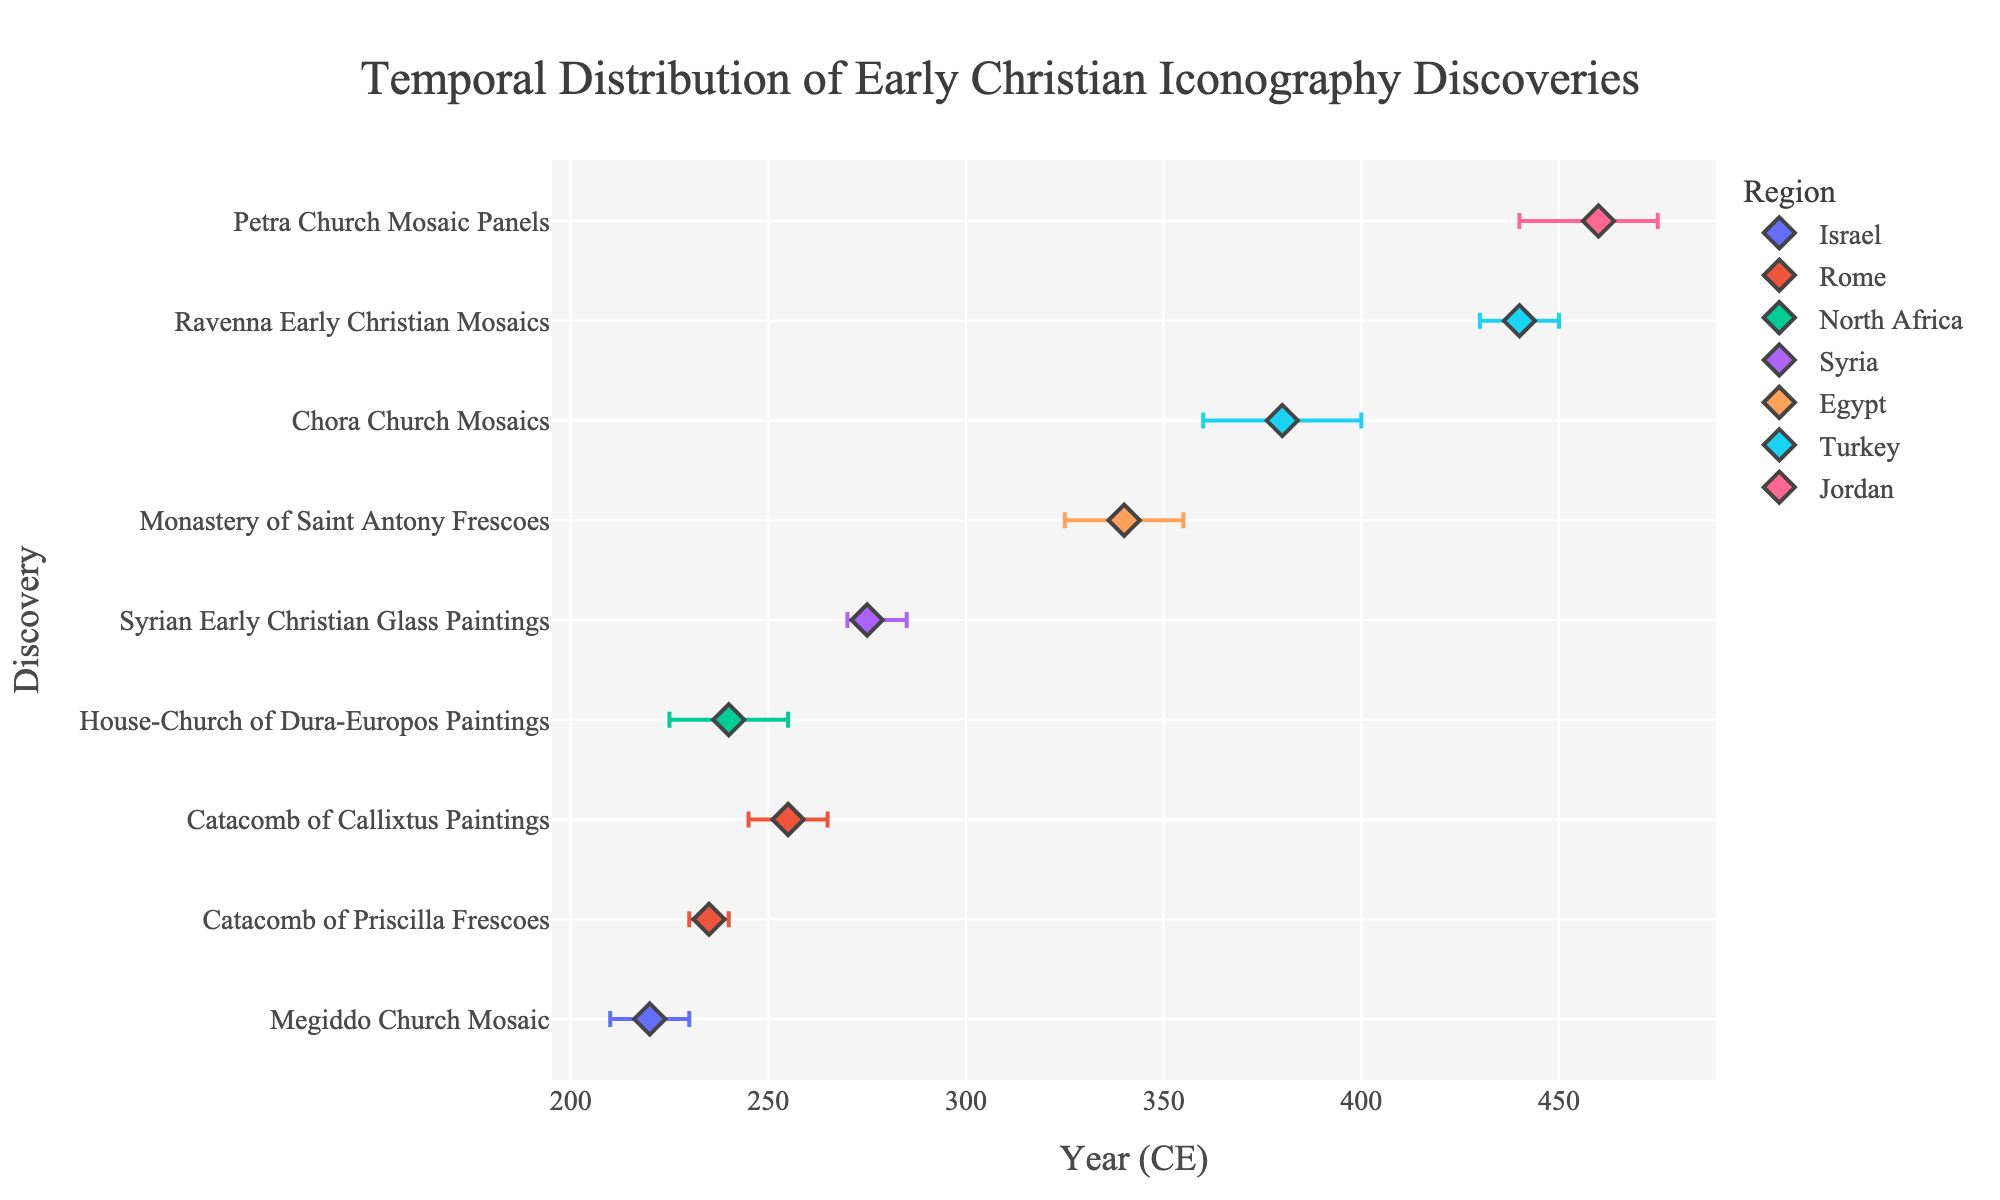What's the title of the plot? The title is located at the top of the plot.
Answer: Temporal Distribution of Early Christian Iconography Discoveries What is the median dating of the Chora Church Mosaics? The median dating is represented by the position of the markers along the x-axis. For Chora Church Mosaics in Turkey, it's located at 380 CE.
Answer: 380 CE Which discovery has the largest error margin? The discovery with the largest error bar width has the most uncertainty in dating. The House-Church of Dura-Europos Paintings in North Africa has margins of 15 years on either side, making a total range of 30 years.
Answer: House-Church of Dura-Europos Paintings Compare the median dating of the Catacomb of Callixtus Paintings and the Petra Church Mosaic Panels. Which one is older? To compare, locate both markers along the x-axis: Catacomb of Callixtus Paintings is at 255 CE, and Petra Church Mosaic Panels is at 460 CE. The older one is the one with the smaller year value.
Answer: Catacomb of Callixtus Paintings How many discoveries are depicted from Turkey? Count the number of markers labeled Turkey in the legend and placed on the plot. There are two: Chora Church Mosaics and Ravenna Early Christian Mosaics.
Answer: 2 What's the date range for the Megiddo Church Mosaic in Israel? Calculate the range by adding the upper and lower error margins to the median dating of 220 CE. The range is from 210 CE to 230 CE.
Answer: 210 CE - 230 CE Which region has the earliest and the latest median dating discovery? Examine the x-axis positions of all markers for each region. The earliest is from Rome (Catacomb of Priscilla Frescoes, 235 CE), and the latest is from Jordan (Petra Church Mosaic Panels, 460 CE).
Answer: Earliest: Rome, Latest: Jordan Are there any discoveries from the same region that are dated within the same century? Check the median dating of discoveries from the same region for overlap within a century. Rome has two discoveries: Catacomb of Callixtus Paintings (255 CE) and Catacomb of Priscilla Frescoes (235 CE), both within the 3rd century.
Answer: Yes, in Rome 